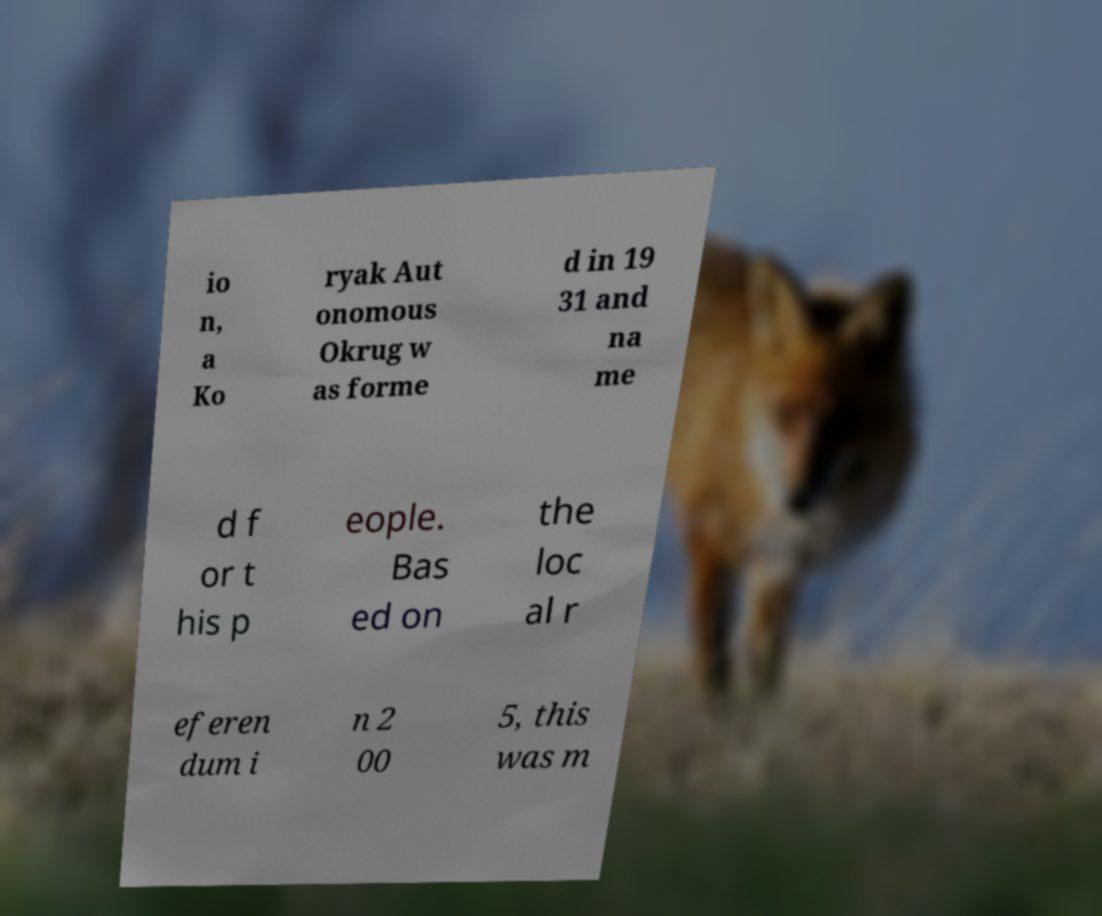I need the written content from this picture converted into text. Can you do that? io n, a Ko ryak Aut onomous Okrug w as forme d in 19 31 and na me d f or t his p eople. Bas ed on the loc al r eferen dum i n 2 00 5, this was m 